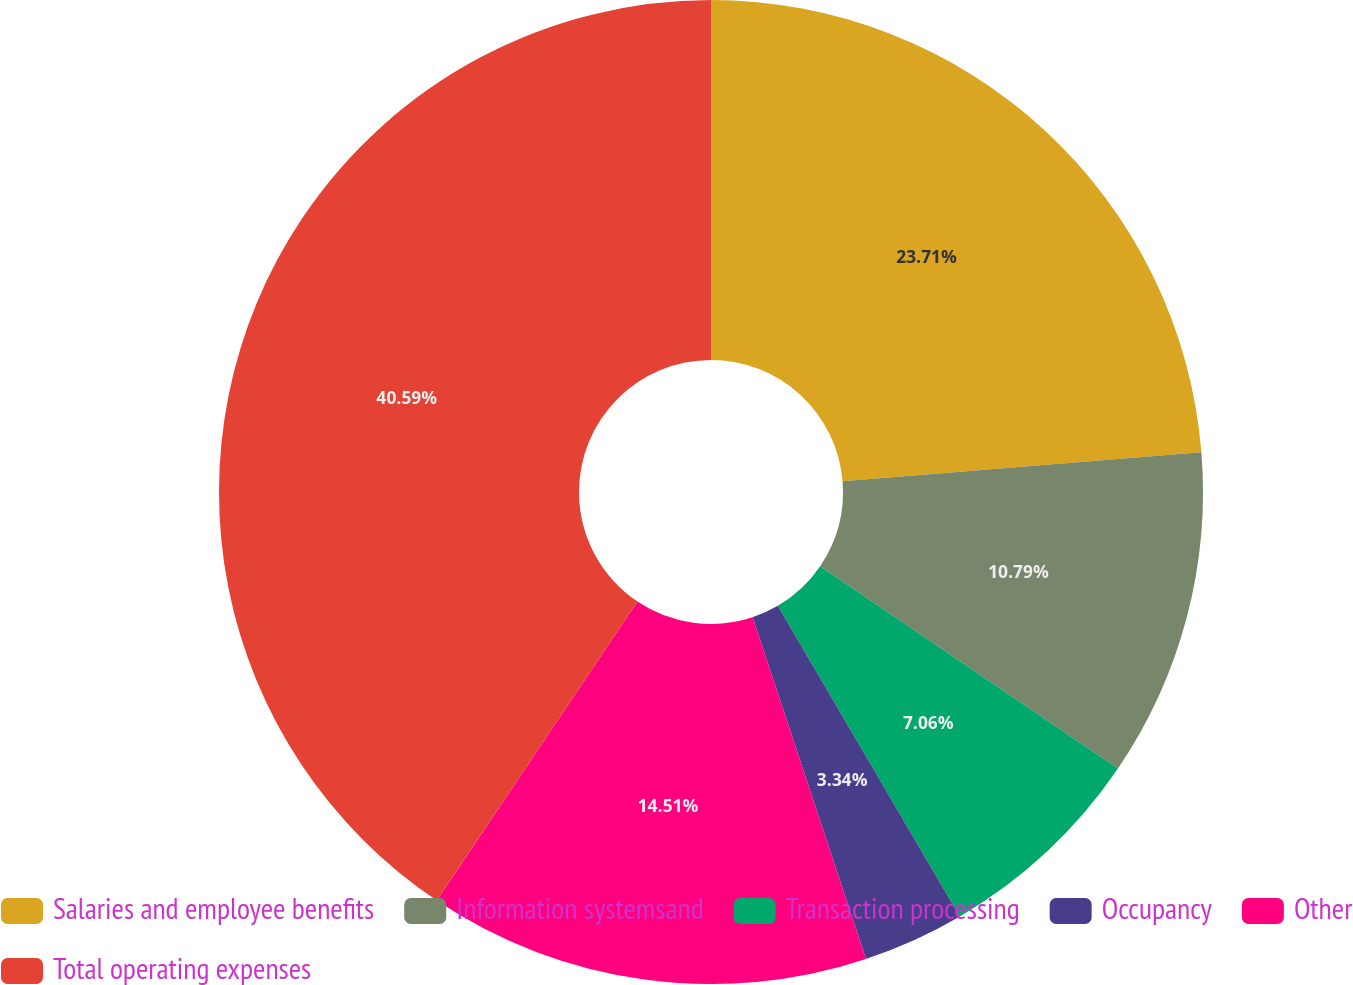<chart> <loc_0><loc_0><loc_500><loc_500><pie_chart><fcel>Salaries and employee benefits<fcel>Information systemsand<fcel>Transaction processing<fcel>Occupancy<fcel>Other<fcel>Total operating expenses<nl><fcel>23.71%<fcel>10.79%<fcel>7.06%<fcel>3.34%<fcel>14.51%<fcel>40.59%<nl></chart> 